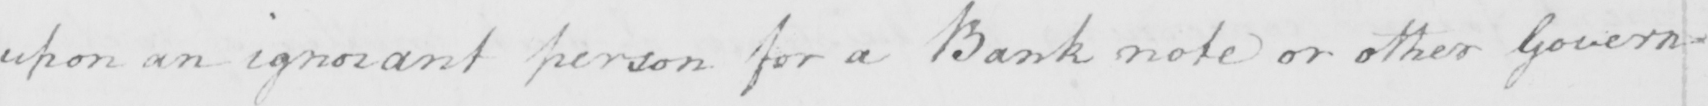What is written in this line of handwriting? upon an ignorant person for a Bank note or other Govern= 